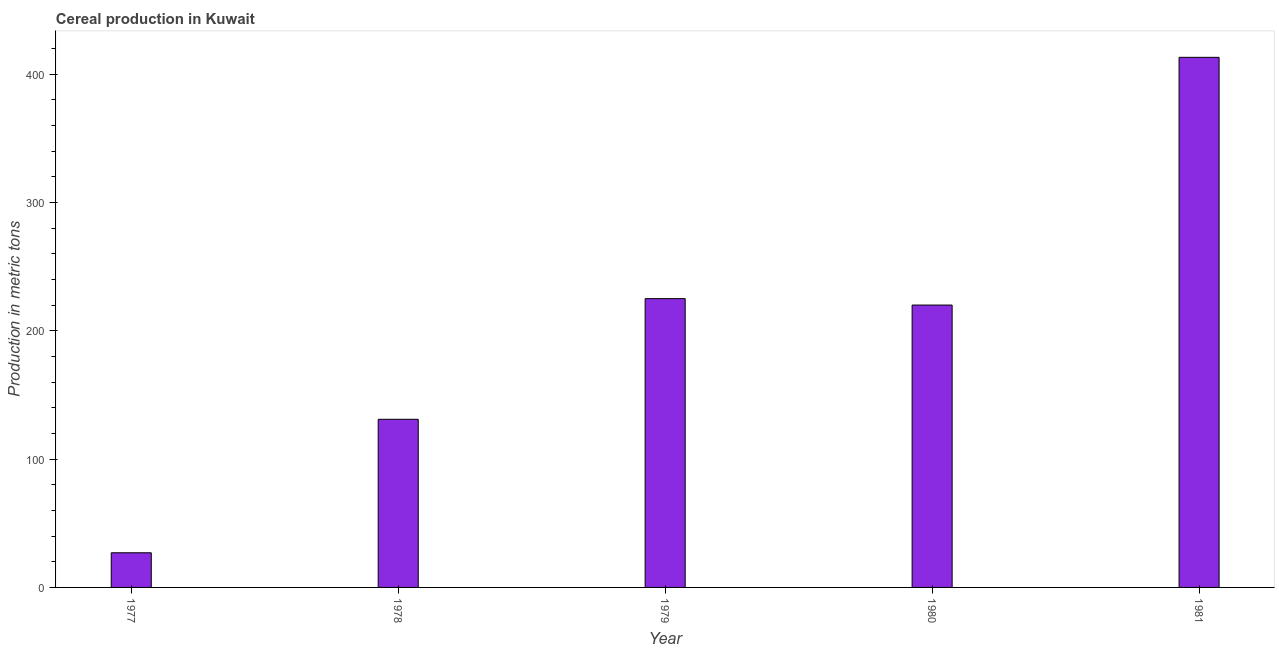Does the graph contain any zero values?
Give a very brief answer. No. Does the graph contain grids?
Provide a short and direct response. No. What is the title of the graph?
Provide a succinct answer. Cereal production in Kuwait. What is the label or title of the Y-axis?
Your response must be concise. Production in metric tons. What is the cereal production in 1977?
Provide a short and direct response. 27. Across all years, what is the maximum cereal production?
Provide a short and direct response. 413. In which year was the cereal production maximum?
Offer a very short reply. 1981. What is the sum of the cereal production?
Make the answer very short. 1016. What is the difference between the cereal production in 1979 and 1981?
Give a very brief answer. -188. What is the average cereal production per year?
Give a very brief answer. 203.2. What is the median cereal production?
Your answer should be compact. 220. In how many years, is the cereal production greater than 80 metric tons?
Offer a very short reply. 4. Do a majority of the years between 1977 and 1981 (inclusive) have cereal production greater than 340 metric tons?
Offer a terse response. No. What is the ratio of the cereal production in 1977 to that in 1979?
Ensure brevity in your answer.  0.12. What is the difference between the highest and the second highest cereal production?
Your response must be concise. 188. What is the difference between the highest and the lowest cereal production?
Provide a succinct answer. 386. In how many years, is the cereal production greater than the average cereal production taken over all years?
Give a very brief answer. 3. Are the values on the major ticks of Y-axis written in scientific E-notation?
Your response must be concise. No. What is the Production in metric tons of 1978?
Make the answer very short. 131. What is the Production in metric tons of 1979?
Your answer should be compact. 225. What is the Production in metric tons of 1980?
Provide a succinct answer. 220. What is the Production in metric tons of 1981?
Make the answer very short. 413. What is the difference between the Production in metric tons in 1977 and 1978?
Your answer should be very brief. -104. What is the difference between the Production in metric tons in 1977 and 1979?
Give a very brief answer. -198. What is the difference between the Production in metric tons in 1977 and 1980?
Your answer should be compact. -193. What is the difference between the Production in metric tons in 1977 and 1981?
Offer a terse response. -386. What is the difference between the Production in metric tons in 1978 and 1979?
Your answer should be very brief. -94. What is the difference between the Production in metric tons in 1978 and 1980?
Give a very brief answer. -89. What is the difference between the Production in metric tons in 1978 and 1981?
Your answer should be very brief. -282. What is the difference between the Production in metric tons in 1979 and 1980?
Your answer should be compact. 5. What is the difference between the Production in metric tons in 1979 and 1981?
Your answer should be compact. -188. What is the difference between the Production in metric tons in 1980 and 1981?
Offer a terse response. -193. What is the ratio of the Production in metric tons in 1977 to that in 1978?
Your answer should be compact. 0.21. What is the ratio of the Production in metric tons in 1977 to that in 1979?
Make the answer very short. 0.12. What is the ratio of the Production in metric tons in 1977 to that in 1980?
Offer a terse response. 0.12. What is the ratio of the Production in metric tons in 1977 to that in 1981?
Ensure brevity in your answer.  0.07. What is the ratio of the Production in metric tons in 1978 to that in 1979?
Provide a succinct answer. 0.58. What is the ratio of the Production in metric tons in 1978 to that in 1980?
Ensure brevity in your answer.  0.59. What is the ratio of the Production in metric tons in 1978 to that in 1981?
Keep it short and to the point. 0.32. What is the ratio of the Production in metric tons in 1979 to that in 1981?
Your response must be concise. 0.55. What is the ratio of the Production in metric tons in 1980 to that in 1981?
Provide a short and direct response. 0.53. 